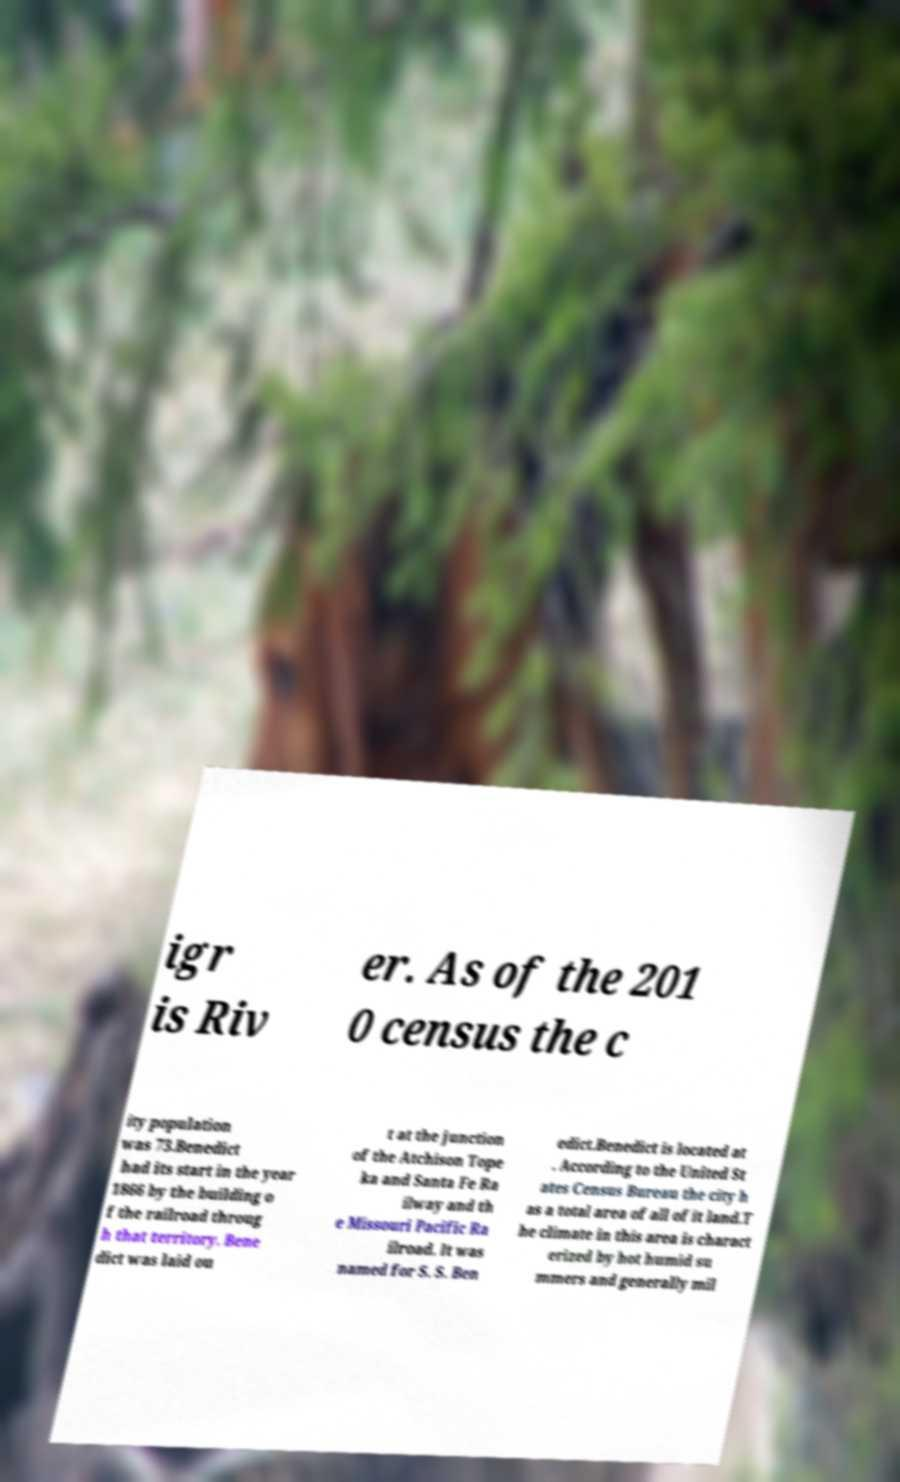Please read and relay the text visible in this image. What does it say? igr is Riv er. As of the 201 0 census the c ity population was 73.Benedict had its start in the year 1866 by the building o f the railroad throug h that territory. Bene dict was laid ou t at the junction of the Atchison Tope ka and Santa Fe Ra ilway and th e Missouri Pacific Ra ilroad. It was named for S. S. Ben edict.Benedict is located at . According to the United St ates Census Bureau the city h as a total area of all of it land.T he climate in this area is charact erized by hot humid su mmers and generally mil 